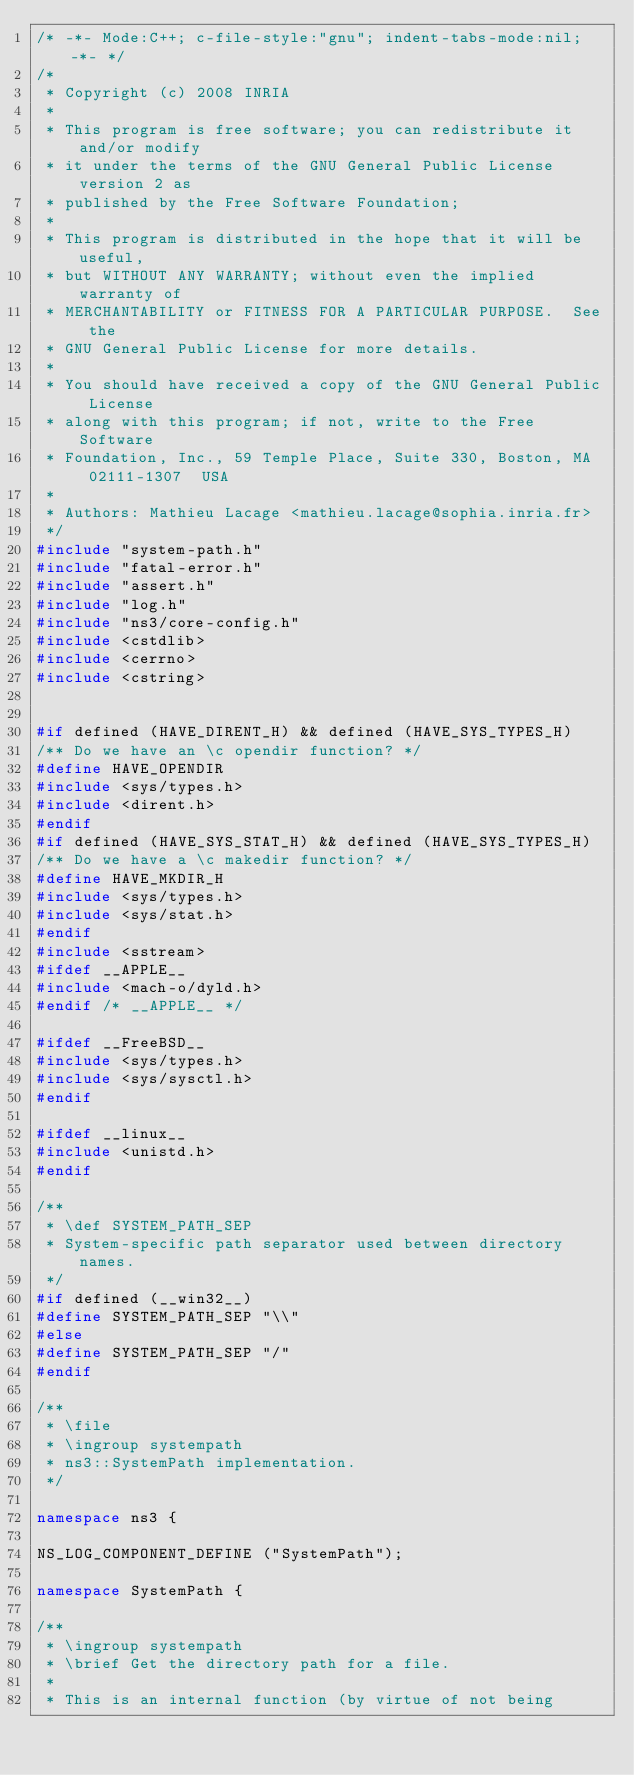<code> <loc_0><loc_0><loc_500><loc_500><_C++_>/* -*- Mode:C++; c-file-style:"gnu"; indent-tabs-mode:nil; -*- */
/*
 * Copyright (c) 2008 INRIA
 *
 * This program is free software; you can redistribute it and/or modify
 * it under the terms of the GNU General Public License version 2 as
 * published by the Free Software Foundation;
 *
 * This program is distributed in the hope that it will be useful,
 * but WITHOUT ANY WARRANTY; without even the implied warranty of
 * MERCHANTABILITY or FITNESS FOR A PARTICULAR PURPOSE.  See the
 * GNU General Public License for more details.
 *
 * You should have received a copy of the GNU General Public License
 * along with this program; if not, write to the Free Software
 * Foundation, Inc., 59 Temple Place, Suite 330, Boston, MA  02111-1307  USA
 *
 * Authors: Mathieu Lacage <mathieu.lacage@sophia.inria.fr>
 */
#include "system-path.h"
#include "fatal-error.h"
#include "assert.h"
#include "log.h"
#include "ns3/core-config.h"
#include <cstdlib>
#include <cerrno>
#include <cstring>


#if defined (HAVE_DIRENT_H) && defined (HAVE_SYS_TYPES_H)
/** Do we have an \c opendir function? */
#define HAVE_OPENDIR
#include <sys/types.h>
#include <dirent.h>
#endif
#if defined (HAVE_SYS_STAT_H) && defined (HAVE_SYS_TYPES_H)
/** Do we have a \c makedir function? */
#define HAVE_MKDIR_H
#include <sys/types.h>
#include <sys/stat.h>
#endif
#include <sstream>
#ifdef __APPLE__
#include <mach-o/dyld.h>
#endif /* __APPLE__ */

#ifdef __FreeBSD__
#include <sys/types.h>
#include <sys/sysctl.h>
#endif

#ifdef __linux__
#include <unistd.h>
#endif

/**
 * \def SYSTEM_PATH_SEP
 * System-specific path separator used between directory names.
 */
#if defined (__win32__)
#define SYSTEM_PATH_SEP "\\"
#else
#define SYSTEM_PATH_SEP "/"
#endif

/**
 * \file
 * \ingroup systempath
 * ns3::SystemPath implementation.
 */

namespace ns3 {

NS_LOG_COMPONENT_DEFINE ("SystemPath");

namespace SystemPath {

/**
 * \ingroup systempath
 * \brief Get the directory path for a file.
 *
 * This is an internal function (by virtue of not being</code> 